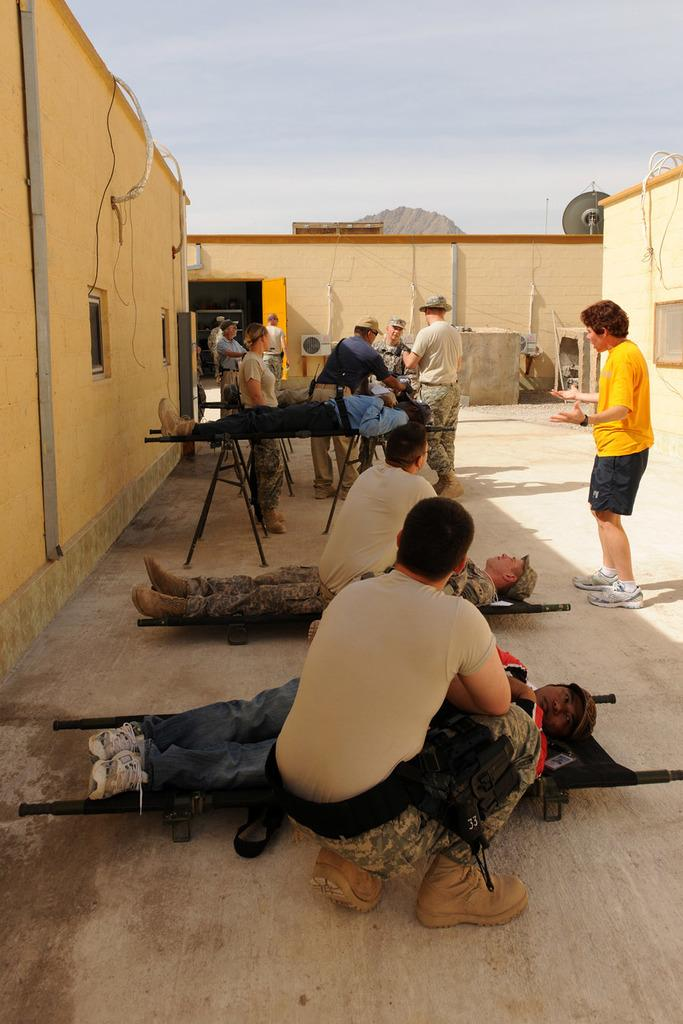What are the soldiers doing in the image? The soldiers are lying on a stretcher in the image. What are the boys doing in the image? The boys are sitting in the image. What can be seen in the background of the image? There is a yellow color wall and a door in the background of the image. What type of pollution is visible in the image? There is no visible pollution in the image. 